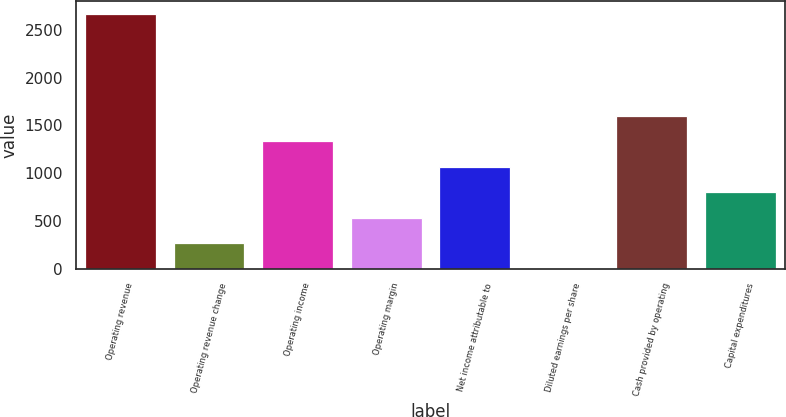Convert chart. <chart><loc_0><loc_0><loc_500><loc_500><bar_chart><fcel>Operating revenue<fcel>Operating revenue change<fcel>Operating income<fcel>Operating margin<fcel>Net income attributable to<fcel>Diluted earnings per share<fcel>Cash provided by operating<fcel>Capital expenditures<nl><fcel>2663.6<fcel>269.56<fcel>1333.59<fcel>535.57<fcel>1067.59<fcel>3.55<fcel>1599.59<fcel>801.58<nl></chart> 